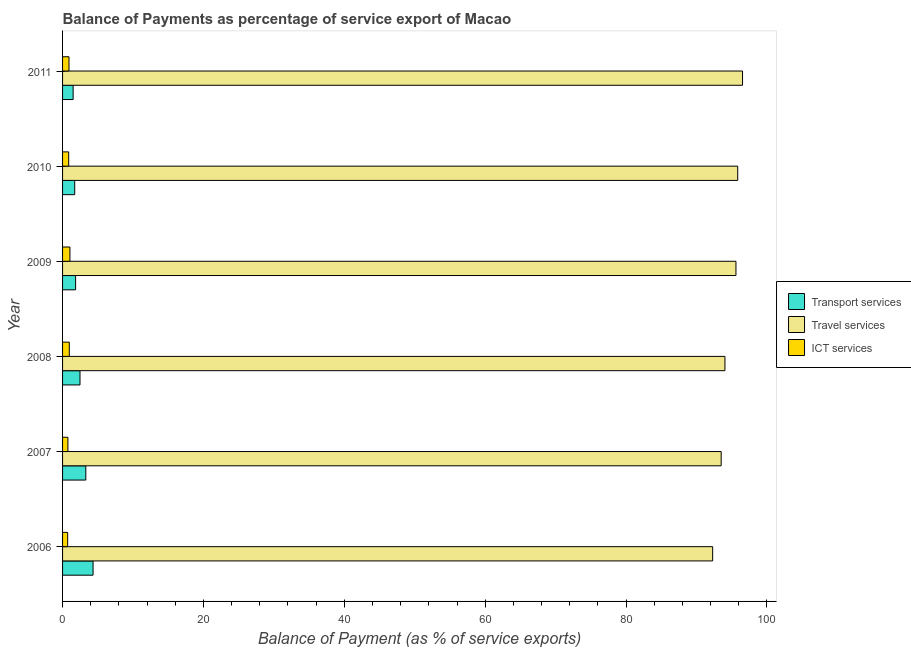How many different coloured bars are there?
Your answer should be very brief. 3. How many bars are there on the 6th tick from the top?
Your answer should be compact. 3. How many bars are there on the 2nd tick from the bottom?
Offer a very short reply. 3. In how many cases, is the number of bars for a given year not equal to the number of legend labels?
Provide a short and direct response. 0. What is the balance of payment of ict services in 2011?
Offer a very short reply. 0.91. Across all years, what is the maximum balance of payment of transport services?
Offer a terse response. 4.33. Across all years, what is the minimum balance of payment of travel services?
Keep it short and to the point. 92.29. In which year was the balance of payment of transport services minimum?
Keep it short and to the point. 2011. What is the total balance of payment of ict services in the graph?
Your answer should be very brief. 5.26. What is the difference between the balance of payment of travel services in 2006 and that in 2011?
Give a very brief answer. -4.24. What is the difference between the balance of payment of ict services in 2007 and the balance of payment of transport services in 2011?
Offer a terse response. -0.74. What is the average balance of payment of ict services per year?
Provide a succinct answer. 0.88. In the year 2008, what is the difference between the balance of payment of transport services and balance of payment of travel services?
Make the answer very short. -91.56. In how many years, is the balance of payment of ict services greater than 76 %?
Provide a short and direct response. 0. What is the ratio of the balance of payment of transport services in 2007 to that in 2011?
Keep it short and to the point. 2.2. What is the difference between the highest and the lowest balance of payment of ict services?
Your answer should be very brief. 0.32. In how many years, is the balance of payment of transport services greater than the average balance of payment of transport services taken over all years?
Make the answer very short. 2. What does the 1st bar from the top in 2010 represents?
Keep it short and to the point. ICT services. What does the 1st bar from the bottom in 2007 represents?
Your response must be concise. Transport services. What is the difference between two consecutive major ticks on the X-axis?
Offer a very short reply. 20. Does the graph contain any zero values?
Keep it short and to the point. No. Does the graph contain grids?
Provide a short and direct response. No. Where does the legend appear in the graph?
Offer a terse response. Center right. How are the legend labels stacked?
Offer a terse response. Vertical. What is the title of the graph?
Keep it short and to the point. Balance of Payments as percentage of service export of Macao. What is the label or title of the X-axis?
Provide a short and direct response. Balance of Payment (as % of service exports). What is the Balance of Payment (as % of service exports) in Transport services in 2006?
Offer a very short reply. 4.33. What is the Balance of Payment (as % of service exports) of Travel services in 2006?
Ensure brevity in your answer.  92.29. What is the Balance of Payment (as % of service exports) in ICT services in 2006?
Offer a very short reply. 0.72. What is the Balance of Payment (as % of service exports) in Transport services in 2007?
Ensure brevity in your answer.  3.3. What is the Balance of Payment (as % of service exports) in Travel services in 2007?
Offer a terse response. 93.5. What is the Balance of Payment (as % of service exports) in ICT services in 2007?
Keep it short and to the point. 0.76. What is the Balance of Payment (as % of service exports) in Transport services in 2008?
Offer a very short reply. 2.48. What is the Balance of Payment (as % of service exports) of Travel services in 2008?
Your answer should be very brief. 94.03. What is the Balance of Payment (as % of service exports) of ICT services in 2008?
Ensure brevity in your answer.  0.96. What is the Balance of Payment (as % of service exports) of Transport services in 2009?
Keep it short and to the point. 1.85. What is the Balance of Payment (as % of service exports) of Travel services in 2009?
Make the answer very short. 95.6. What is the Balance of Payment (as % of service exports) of ICT services in 2009?
Ensure brevity in your answer.  1.04. What is the Balance of Payment (as % of service exports) in Transport services in 2010?
Provide a succinct answer. 1.72. What is the Balance of Payment (as % of service exports) of Travel services in 2010?
Your response must be concise. 95.85. What is the Balance of Payment (as % of service exports) in ICT services in 2010?
Offer a very short reply. 0.87. What is the Balance of Payment (as % of service exports) in Transport services in 2011?
Your response must be concise. 1.5. What is the Balance of Payment (as % of service exports) of Travel services in 2011?
Provide a short and direct response. 96.53. What is the Balance of Payment (as % of service exports) in ICT services in 2011?
Make the answer very short. 0.91. Across all years, what is the maximum Balance of Payment (as % of service exports) in Transport services?
Your response must be concise. 4.33. Across all years, what is the maximum Balance of Payment (as % of service exports) in Travel services?
Keep it short and to the point. 96.53. Across all years, what is the maximum Balance of Payment (as % of service exports) in ICT services?
Provide a short and direct response. 1.04. Across all years, what is the minimum Balance of Payment (as % of service exports) in Transport services?
Provide a succinct answer. 1.5. Across all years, what is the minimum Balance of Payment (as % of service exports) of Travel services?
Offer a very short reply. 92.29. Across all years, what is the minimum Balance of Payment (as % of service exports) of ICT services?
Provide a short and direct response. 0.72. What is the total Balance of Payment (as % of service exports) in Transport services in the graph?
Provide a short and direct response. 15.18. What is the total Balance of Payment (as % of service exports) of Travel services in the graph?
Your answer should be very brief. 567.79. What is the total Balance of Payment (as % of service exports) in ICT services in the graph?
Your response must be concise. 5.26. What is the difference between the Balance of Payment (as % of service exports) of Transport services in 2006 and that in 2007?
Ensure brevity in your answer.  1.03. What is the difference between the Balance of Payment (as % of service exports) of Travel services in 2006 and that in 2007?
Keep it short and to the point. -1.21. What is the difference between the Balance of Payment (as % of service exports) of ICT services in 2006 and that in 2007?
Give a very brief answer. -0.04. What is the difference between the Balance of Payment (as % of service exports) in Transport services in 2006 and that in 2008?
Make the answer very short. 1.86. What is the difference between the Balance of Payment (as % of service exports) of Travel services in 2006 and that in 2008?
Keep it short and to the point. -1.74. What is the difference between the Balance of Payment (as % of service exports) of ICT services in 2006 and that in 2008?
Give a very brief answer. -0.23. What is the difference between the Balance of Payment (as % of service exports) in Transport services in 2006 and that in 2009?
Offer a terse response. 2.48. What is the difference between the Balance of Payment (as % of service exports) of Travel services in 2006 and that in 2009?
Your answer should be very brief. -3.31. What is the difference between the Balance of Payment (as % of service exports) in ICT services in 2006 and that in 2009?
Keep it short and to the point. -0.32. What is the difference between the Balance of Payment (as % of service exports) of Transport services in 2006 and that in 2010?
Your answer should be very brief. 2.61. What is the difference between the Balance of Payment (as % of service exports) of Travel services in 2006 and that in 2010?
Keep it short and to the point. -3.56. What is the difference between the Balance of Payment (as % of service exports) of ICT services in 2006 and that in 2010?
Provide a succinct answer. -0.15. What is the difference between the Balance of Payment (as % of service exports) in Transport services in 2006 and that in 2011?
Offer a terse response. 2.83. What is the difference between the Balance of Payment (as % of service exports) of Travel services in 2006 and that in 2011?
Make the answer very short. -4.24. What is the difference between the Balance of Payment (as % of service exports) of ICT services in 2006 and that in 2011?
Provide a short and direct response. -0.19. What is the difference between the Balance of Payment (as % of service exports) in Transport services in 2007 and that in 2008?
Ensure brevity in your answer.  0.82. What is the difference between the Balance of Payment (as % of service exports) of Travel services in 2007 and that in 2008?
Your answer should be compact. -0.53. What is the difference between the Balance of Payment (as % of service exports) of ICT services in 2007 and that in 2008?
Make the answer very short. -0.2. What is the difference between the Balance of Payment (as % of service exports) in Transport services in 2007 and that in 2009?
Give a very brief answer. 1.45. What is the difference between the Balance of Payment (as % of service exports) of Travel services in 2007 and that in 2009?
Your answer should be compact. -2.1. What is the difference between the Balance of Payment (as % of service exports) of ICT services in 2007 and that in 2009?
Provide a succinct answer. -0.28. What is the difference between the Balance of Payment (as % of service exports) of Transport services in 2007 and that in 2010?
Offer a terse response. 1.57. What is the difference between the Balance of Payment (as % of service exports) of Travel services in 2007 and that in 2010?
Offer a terse response. -2.35. What is the difference between the Balance of Payment (as % of service exports) of ICT services in 2007 and that in 2010?
Your answer should be compact. -0.11. What is the difference between the Balance of Payment (as % of service exports) in Transport services in 2007 and that in 2011?
Your response must be concise. 1.8. What is the difference between the Balance of Payment (as % of service exports) of Travel services in 2007 and that in 2011?
Keep it short and to the point. -3.03. What is the difference between the Balance of Payment (as % of service exports) in ICT services in 2007 and that in 2011?
Give a very brief answer. -0.15. What is the difference between the Balance of Payment (as % of service exports) of Transport services in 2008 and that in 2009?
Keep it short and to the point. 0.62. What is the difference between the Balance of Payment (as % of service exports) of Travel services in 2008 and that in 2009?
Offer a terse response. -1.56. What is the difference between the Balance of Payment (as % of service exports) of ICT services in 2008 and that in 2009?
Your answer should be very brief. -0.09. What is the difference between the Balance of Payment (as % of service exports) of Transport services in 2008 and that in 2010?
Your response must be concise. 0.75. What is the difference between the Balance of Payment (as % of service exports) of Travel services in 2008 and that in 2010?
Offer a terse response. -1.81. What is the difference between the Balance of Payment (as % of service exports) of ICT services in 2008 and that in 2010?
Provide a short and direct response. 0.09. What is the difference between the Balance of Payment (as % of service exports) of Transport services in 2008 and that in 2011?
Provide a succinct answer. 0.97. What is the difference between the Balance of Payment (as % of service exports) in Travel services in 2008 and that in 2011?
Ensure brevity in your answer.  -2.5. What is the difference between the Balance of Payment (as % of service exports) in ICT services in 2008 and that in 2011?
Keep it short and to the point. 0.04. What is the difference between the Balance of Payment (as % of service exports) of Transport services in 2009 and that in 2010?
Give a very brief answer. 0.13. What is the difference between the Balance of Payment (as % of service exports) in Travel services in 2009 and that in 2010?
Your answer should be compact. -0.25. What is the difference between the Balance of Payment (as % of service exports) in ICT services in 2009 and that in 2010?
Offer a terse response. 0.17. What is the difference between the Balance of Payment (as % of service exports) of Transport services in 2009 and that in 2011?
Offer a terse response. 0.35. What is the difference between the Balance of Payment (as % of service exports) in Travel services in 2009 and that in 2011?
Make the answer very short. -0.93. What is the difference between the Balance of Payment (as % of service exports) in ICT services in 2009 and that in 2011?
Your answer should be very brief. 0.13. What is the difference between the Balance of Payment (as % of service exports) of Transport services in 2010 and that in 2011?
Keep it short and to the point. 0.23. What is the difference between the Balance of Payment (as % of service exports) of Travel services in 2010 and that in 2011?
Your answer should be very brief. -0.68. What is the difference between the Balance of Payment (as % of service exports) of ICT services in 2010 and that in 2011?
Your answer should be compact. -0.04. What is the difference between the Balance of Payment (as % of service exports) in Transport services in 2006 and the Balance of Payment (as % of service exports) in Travel services in 2007?
Keep it short and to the point. -89.17. What is the difference between the Balance of Payment (as % of service exports) in Transport services in 2006 and the Balance of Payment (as % of service exports) in ICT services in 2007?
Your answer should be very brief. 3.57. What is the difference between the Balance of Payment (as % of service exports) of Travel services in 2006 and the Balance of Payment (as % of service exports) of ICT services in 2007?
Make the answer very short. 91.53. What is the difference between the Balance of Payment (as % of service exports) of Transport services in 2006 and the Balance of Payment (as % of service exports) of Travel services in 2008?
Keep it short and to the point. -89.7. What is the difference between the Balance of Payment (as % of service exports) in Transport services in 2006 and the Balance of Payment (as % of service exports) in ICT services in 2008?
Your response must be concise. 3.37. What is the difference between the Balance of Payment (as % of service exports) in Travel services in 2006 and the Balance of Payment (as % of service exports) in ICT services in 2008?
Make the answer very short. 91.33. What is the difference between the Balance of Payment (as % of service exports) of Transport services in 2006 and the Balance of Payment (as % of service exports) of Travel services in 2009?
Ensure brevity in your answer.  -91.27. What is the difference between the Balance of Payment (as % of service exports) in Transport services in 2006 and the Balance of Payment (as % of service exports) in ICT services in 2009?
Offer a terse response. 3.29. What is the difference between the Balance of Payment (as % of service exports) in Travel services in 2006 and the Balance of Payment (as % of service exports) in ICT services in 2009?
Give a very brief answer. 91.25. What is the difference between the Balance of Payment (as % of service exports) of Transport services in 2006 and the Balance of Payment (as % of service exports) of Travel services in 2010?
Your answer should be compact. -91.52. What is the difference between the Balance of Payment (as % of service exports) of Transport services in 2006 and the Balance of Payment (as % of service exports) of ICT services in 2010?
Your response must be concise. 3.46. What is the difference between the Balance of Payment (as % of service exports) in Travel services in 2006 and the Balance of Payment (as % of service exports) in ICT services in 2010?
Make the answer very short. 91.42. What is the difference between the Balance of Payment (as % of service exports) of Transport services in 2006 and the Balance of Payment (as % of service exports) of Travel services in 2011?
Provide a short and direct response. -92.2. What is the difference between the Balance of Payment (as % of service exports) of Transport services in 2006 and the Balance of Payment (as % of service exports) of ICT services in 2011?
Make the answer very short. 3.42. What is the difference between the Balance of Payment (as % of service exports) of Travel services in 2006 and the Balance of Payment (as % of service exports) of ICT services in 2011?
Give a very brief answer. 91.38. What is the difference between the Balance of Payment (as % of service exports) in Transport services in 2007 and the Balance of Payment (as % of service exports) in Travel services in 2008?
Give a very brief answer. -90.73. What is the difference between the Balance of Payment (as % of service exports) in Transport services in 2007 and the Balance of Payment (as % of service exports) in ICT services in 2008?
Your answer should be very brief. 2.34. What is the difference between the Balance of Payment (as % of service exports) of Travel services in 2007 and the Balance of Payment (as % of service exports) of ICT services in 2008?
Your answer should be compact. 92.54. What is the difference between the Balance of Payment (as % of service exports) of Transport services in 2007 and the Balance of Payment (as % of service exports) of Travel services in 2009?
Provide a short and direct response. -92.3. What is the difference between the Balance of Payment (as % of service exports) in Transport services in 2007 and the Balance of Payment (as % of service exports) in ICT services in 2009?
Make the answer very short. 2.26. What is the difference between the Balance of Payment (as % of service exports) of Travel services in 2007 and the Balance of Payment (as % of service exports) of ICT services in 2009?
Give a very brief answer. 92.45. What is the difference between the Balance of Payment (as % of service exports) in Transport services in 2007 and the Balance of Payment (as % of service exports) in Travel services in 2010?
Give a very brief answer. -92.55. What is the difference between the Balance of Payment (as % of service exports) of Transport services in 2007 and the Balance of Payment (as % of service exports) of ICT services in 2010?
Provide a succinct answer. 2.43. What is the difference between the Balance of Payment (as % of service exports) in Travel services in 2007 and the Balance of Payment (as % of service exports) in ICT services in 2010?
Your answer should be very brief. 92.63. What is the difference between the Balance of Payment (as % of service exports) in Transport services in 2007 and the Balance of Payment (as % of service exports) in Travel services in 2011?
Offer a terse response. -93.23. What is the difference between the Balance of Payment (as % of service exports) in Transport services in 2007 and the Balance of Payment (as % of service exports) in ICT services in 2011?
Give a very brief answer. 2.39. What is the difference between the Balance of Payment (as % of service exports) of Travel services in 2007 and the Balance of Payment (as % of service exports) of ICT services in 2011?
Offer a terse response. 92.59. What is the difference between the Balance of Payment (as % of service exports) in Transport services in 2008 and the Balance of Payment (as % of service exports) in Travel services in 2009?
Keep it short and to the point. -93.12. What is the difference between the Balance of Payment (as % of service exports) of Transport services in 2008 and the Balance of Payment (as % of service exports) of ICT services in 2009?
Offer a terse response. 1.43. What is the difference between the Balance of Payment (as % of service exports) of Travel services in 2008 and the Balance of Payment (as % of service exports) of ICT services in 2009?
Your response must be concise. 92.99. What is the difference between the Balance of Payment (as % of service exports) in Transport services in 2008 and the Balance of Payment (as % of service exports) in Travel services in 2010?
Make the answer very short. -93.37. What is the difference between the Balance of Payment (as % of service exports) in Transport services in 2008 and the Balance of Payment (as % of service exports) in ICT services in 2010?
Give a very brief answer. 1.61. What is the difference between the Balance of Payment (as % of service exports) in Travel services in 2008 and the Balance of Payment (as % of service exports) in ICT services in 2010?
Keep it short and to the point. 93.16. What is the difference between the Balance of Payment (as % of service exports) of Transport services in 2008 and the Balance of Payment (as % of service exports) of Travel services in 2011?
Offer a very short reply. -94.05. What is the difference between the Balance of Payment (as % of service exports) in Transport services in 2008 and the Balance of Payment (as % of service exports) in ICT services in 2011?
Your answer should be very brief. 1.56. What is the difference between the Balance of Payment (as % of service exports) of Travel services in 2008 and the Balance of Payment (as % of service exports) of ICT services in 2011?
Keep it short and to the point. 93.12. What is the difference between the Balance of Payment (as % of service exports) of Transport services in 2009 and the Balance of Payment (as % of service exports) of Travel services in 2010?
Provide a short and direct response. -93.99. What is the difference between the Balance of Payment (as % of service exports) in Transport services in 2009 and the Balance of Payment (as % of service exports) in ICT services in 2010?
Ensure brevity in your answer.  0.98. What is the difference between the Balance of Payment (as % of service exports) of Travel services in 2009 and the Balance of Payment (as % of service exports) of ICT services in 2010?
Provide a succinct answer. 94.73. What is the difference between the Balance of Payment (as % of service exports) of Transport services in 2009 and the Balance of Payment (as % of service exports) of Travel services in 2011?
Provide a short and direct response. -94.68. What is the difference between the Balance of Payment (as % of service exports) of Transport services in 2009 and the Balance of Payment (as % of service exports) of ICT services in 2011?
Ensure brevity in your answer.  0.94. What is the difference between the Balance of Payment (as % of service exports) of Travel services in 2009 and the Balance of Payment (as % of service exports) of ICT services in 2011?
Offer a terse response. 94.69. What is the difference between the Balance of Payment (as % of service exports) in Transport services in 2010 and the Balance of Payment (as % of service exports) in Travel services in 2011?
Provide a short and direct response. -94.8. What is the difference between the Balance of Payment (as % of service exports) of Transport services in 2010 and the Balance of Payment (as % of service exports) of ICT services in 2011?
Ensure brevity in your answer.  0.81. What is the difference between the Balance of Payment (as % of service exports) of Travel services in 2010 and the Balance of Payment (as % of service exports) of ICT services in 2011?
Ensure brevity in your answer.  94.94. What is the average Balance of Payment (as % of service exports) of Transport services per year?
Offer a terse response. 2.53. What is the average Balance of Payment (as % of service exports) in Travel services per year?
Ensure brevity in your answer.  94.63. What is the average Balance of Payment (as % of service exports) in ICT services per year?
Give a very brief answer. 0.88. In the year 2006, what is the difference between the Balance of Payment (as % of service exports) of Transport services and Balance of Payment (as % of service exports) of Travel services?
Offer a terse response. -87.96. In the year 2006, what is the difference between the Balance of Payment (as % of service exports) of Transport services and Balance of Payment (as % of service exports) of ICT services?
Provide a succinct answer. 3.61. In the year 2006, what is the difference between the Balance of Payment (as % of service exports) in Travel services and Balance of Payment (as % of service exports) in ICT services?
Your response must be concise. 91.56. In the year 2007, what is the difference between the Balance of Payment (as % of service exports) in Transport services and Balance of Payment (as % of service exports) in Travel services?
Ensure brevity in your answer.  -90.2. In the year 2007, what is the difference between the Balance of Payment (as % of service exports) in Transport services and Balance of Payment (as % of service exports) in ICT services?
Your answer should be very brief. 2.54. In the year 2007, what is the difference between the Balance of Payment (as % of service exports) in Travel services and Balance of Payment (as % of service exports) in ICT services?
Keep it short and to the point. 92.74. In the year 2008, what is the difference between the Balance of Payment (as % of service exports) in Transport services and Balance of Payment (as % of service exports) in Travel services?
Ensure brevity in your answer.  -91.56. In the year 2008, what is the difference between the Balance of Payment (as % of service exports) of Transport services and Balance of Payment (as % of service exports) of ICT services?
Offer a very short reply. 1.52. In the year 2008, what is the difference between the Balance of Payment (as % of service exports) in Travel services and Balance of Payment (as % of service exports) in ICT services?
Your answer should be compact. 93.08. In the year 2009, what is the difference between the Balance of Payment (as % of service exports) of Transport services and Balance of Payment (as % of service exports) of Travel services?
Ensure brevity in your answer.  -93.75. In the year 2009, what is the difference between the Balance of Payment (as % of service exports) in Transport services and Balance of Payment (as % of service exports) in ICT services?
Make the answer very short. 0.81. In the year 2009, what is the difference between the Balance of Payment (as % of service exports) in Travel services and Balance of Payment (as % of service exports) in ICT services?
Offer a terse response. 94.55. In the year 2010, what is the difference between the Balance of Payment (as % of service exports) in Transport services and Balance of Payment (as % of service exports) in Travel services?
Offer a very short reply. -94.12. In the year 2010, what is the difference between the Balance of Payment (as % of service exports) of Transport services and Balance of Payment (as % of service exports) of ICT services?
Provide a succinct answer. 0.86. In the year 2010, what is the difference between the Balance of Payment (as % of service exports) in Travel services and Balance of Payment (as % of service exports) in ICT services?
Make the answer very short. 94.98. In the year 2011, what is the difference between the Balance of Payment (as % of service exports) in Transport services and Balance of Payment (as % of service exports) in Travel services?
Provide a succinct answer. -95.03. In the year 2011, what is the difference between the Balance of Payment (as % of service exports) of Transport services and Balance of Payment (as % of service exports) of ICT services?
Ensure brevity in your answer.  0.59. In the year 2011, what is the difference between the Balance of Payment (as % of service exports) of Travel services and Balance of Payment (as % of service exports) of ICT services?
Your response must be concise. 95.62. What is the ratio of the Balance of Payment (as % of service exports) of Transport services in 2006 to that in 2007?
Your answer should be compact. 1.31. What is the ratio of the Balance of Payment (as % of service exports) in Travel services in 2006 to that in 2007?
Offer a very short reply. 0.99. What is the ratio of the Balance of Payment (as % of service exports) in ICT services in 2006 to that in 2007?
Give a very brief answer. 0.95. What is the ratio of the Balance of Payment (as % of service exports) in Transport services in 2006 to that in 2008?
Give a very brief answer. 1.75. What is the ratio of the Balance of Payment (as % of service exports) of Travel services in 2006 to that in 2008?
Your answer should be compact. 0.98. What is the ratio of the Balance of Payment (as % of service exports) in ICT services in 2006 to that in 2008?
Your answer should be compact. 0.76. What is the ratio of the Balance of Payment (as % of service exports) of Transport services in 2006 to that in 2009?
Ensure brevity in your answer.  2.34. What is the ratio of the Balance of Payment (as % of service exports) in Travel services in 2006 to that in 2009?
Keep it short and to the point. 0.97. What is the ratio of the Balance of Payment (as % of service exports) of ICT services in 2006 to that in 2009?
Provide a short and direct response. 0.69. What is the ratio of the Balance of Payment (as % of service exports) of Transport services in 2006 to that in 2010?
Give a very brief answer. 2.51. What is the ratio of the Balance of Payment (as % of service exports) in Travel services in 2006 to that in 2010?
Make the answer very short. 0.96. What is the ratio of the Balance of Payment (as % of service exports) of ICT services in 2006 to that in 2010?
Your answer should be compact. 0.83. What is the ratio of the Balance of Payment (as % of service exports) in Transport services in 2006 to that in 2011?
Offer a very short reply. 2.89. What is the ratio of the Balance of Payment (as % of service exports) of Travel services in 2006 to that in 2011?
Offer a terse response. 0.96. What is the ratio of the Balance of Payment (as % of service exports) of ICT services in 2006 to that in 2011?
Ensure brevity in your answer.  0.8. What is the ratio of the Balance of Payment (as % of service exports) in Travel services in 2007 to that in 2008?
Offer a very short reply. 0.99. What is the ratio of the Balance of Payment (as % of service exports) in ICT services in 2007 to that in 2008?
Give a very brief answer. 0.79. What is the ratio of the Balance of Payment (as % of service exports) in Transport services in 2007 to that in 2009?
Offer a terse response. 1.78. What is the ratio of the Balance of Payment (as % of service exports) in Travel services in 2007 to that in 2009?
Offer a terse response. 0.98. What is the ratio of the Balance of Payment (as % of service exports) of ICT services in 2007 to that in 2009?
Your response must be concise. 0.73. What is the ratio of the Balance of Payment (as % of service exports) of Transport services in 2007 to that in 2010?
Keep it short and to the point. 1.91. What is the ratio of the Balance of Payment (as % of service exports) of Travel services in 2007 to that in 2010?
Your response must be concise. 0.98. What is the ratio of the Balance of Payment (as % of service exports) in ICT services in 2007 to that in 2010?
Your response must be concise. 0.87. What is the ratio of the Balance of Payment (as % of service exports) of Transport services in 2007 to that in 2011?
Make the answer very short. 2.2. What is the ratio of the Balance of Payment (as % of service exports) of Travel services in 2007 to that in 2011?
Offer a very short reply. 0.97. What is the ratio of the Balance of Payment (as % of service exports) in ICT services in 2007 to that in 2011?
Your answer should be very brief. 0.83. What is the ratio of the Balance of Payment (as % of service exports) in Transport services in 2008 to that in 2009?
Your response must be concise. 1.34. What is the ratio of the Balance of Payment (as % of service exports) in Travel services in 2008 to that in 2009?
Give a very brief answer. 0.98. What is the ratio of the Balance of Payment (as % of service exports) in ICT services in 2008 to that in 2009?
Provide a succinct answer. 0.92. What is the ratio of the Balance of Payment (as % of service exports) of Transport services in 2008 to that in 2010?
Provide a succinct answer. 1.43. What is the ratio of the Balance of Payment (as % of service exports) in Travel services in 2008 to that in 2010?
Provide a short and direct response. 0.98. What is the ratio of the Balance of Payment (as % of service exports) of ICT services in 2008 to that in 2010?
Offer a very short reply. 1.1. What is the ratio of the Balance of Payment (as % of service exports) of Transport services in 2008 to that in 2011?
Keep it short and to the point. 1.65. What is the ratio of the Balance of Payment (as % of service exports) in Travel services in 2008 to that in 2011?
Ensure brevity in your answer.  0.97. What is the ratio of the Balance of Payment (as % of service exports) in ICT services in 2008 to that in 2011?
Provide a succinct answer. 1.05. What is the ratio of the Balance of Payment (as % of service exports) in Transport services in 2009 to that in 2010?
Provide a succinct answer. 1.07. What is the ratio of the Balance of Payment (as % of service exports) in ICT services in 2009 to that in 2010?
Your answer should be compact. 1.2. What is the ratio of the Balance of Payment (as % of service exports) in Transport services in 2009 to that in 2011?
Your response must be concise. 1.23. What is the ratio of the Balance of Payment (as % of service exports) of Travel services in 2009 to that in 2011?
Provide a short and direct response. 0.99. What is the ratio of the Balance of Payment (as % of service exports) of ICT services in 2009 to that in 2011?
Provide a succinct answer. 1.15. What is the ratio of the Balance of Payment (as % of service exports) of Transport services in 2010 to that in 2011?
Provide a short and direct response. 1.15. What is the ratio of the Balance of Payment (as % of service exports) of Travel services in 2010 to that in 2011?
Provide a succinct answer. 0.99. What is the ratio of the Balance of Payment (as % of service exports) of ICT services in 2010 to that in 2011?
Keep it short and to the point. 0.95. What is the difference between the highest and the second highest Balance of Payment (as % of service exports) in Transport services?
Keep it short and to the point. 1.03. What is the difference between the highest and the second highest Balance of Payment (as % of service exports) of Travel services?
Your answer should be compact. 0.68. What is the difference between the highest and the second highest Balance of Payment (as % of service exports) in ICT services?
Keep it short and to the point. 0.09. What is the difference between the highest and the lowest Balance of Payment (as % of service exports) of Transport services?
Your response must be concise. 2.83. What is the difference between the highest and the lowest Balance of Payment (as % of service exports) in Travel services?
Keep it short and to the point. 4.24. What is the difference between the highest and the lowest Balance of Payment (as % of service exports) of ICT services?
Keep it short and to the point. 0.32. 